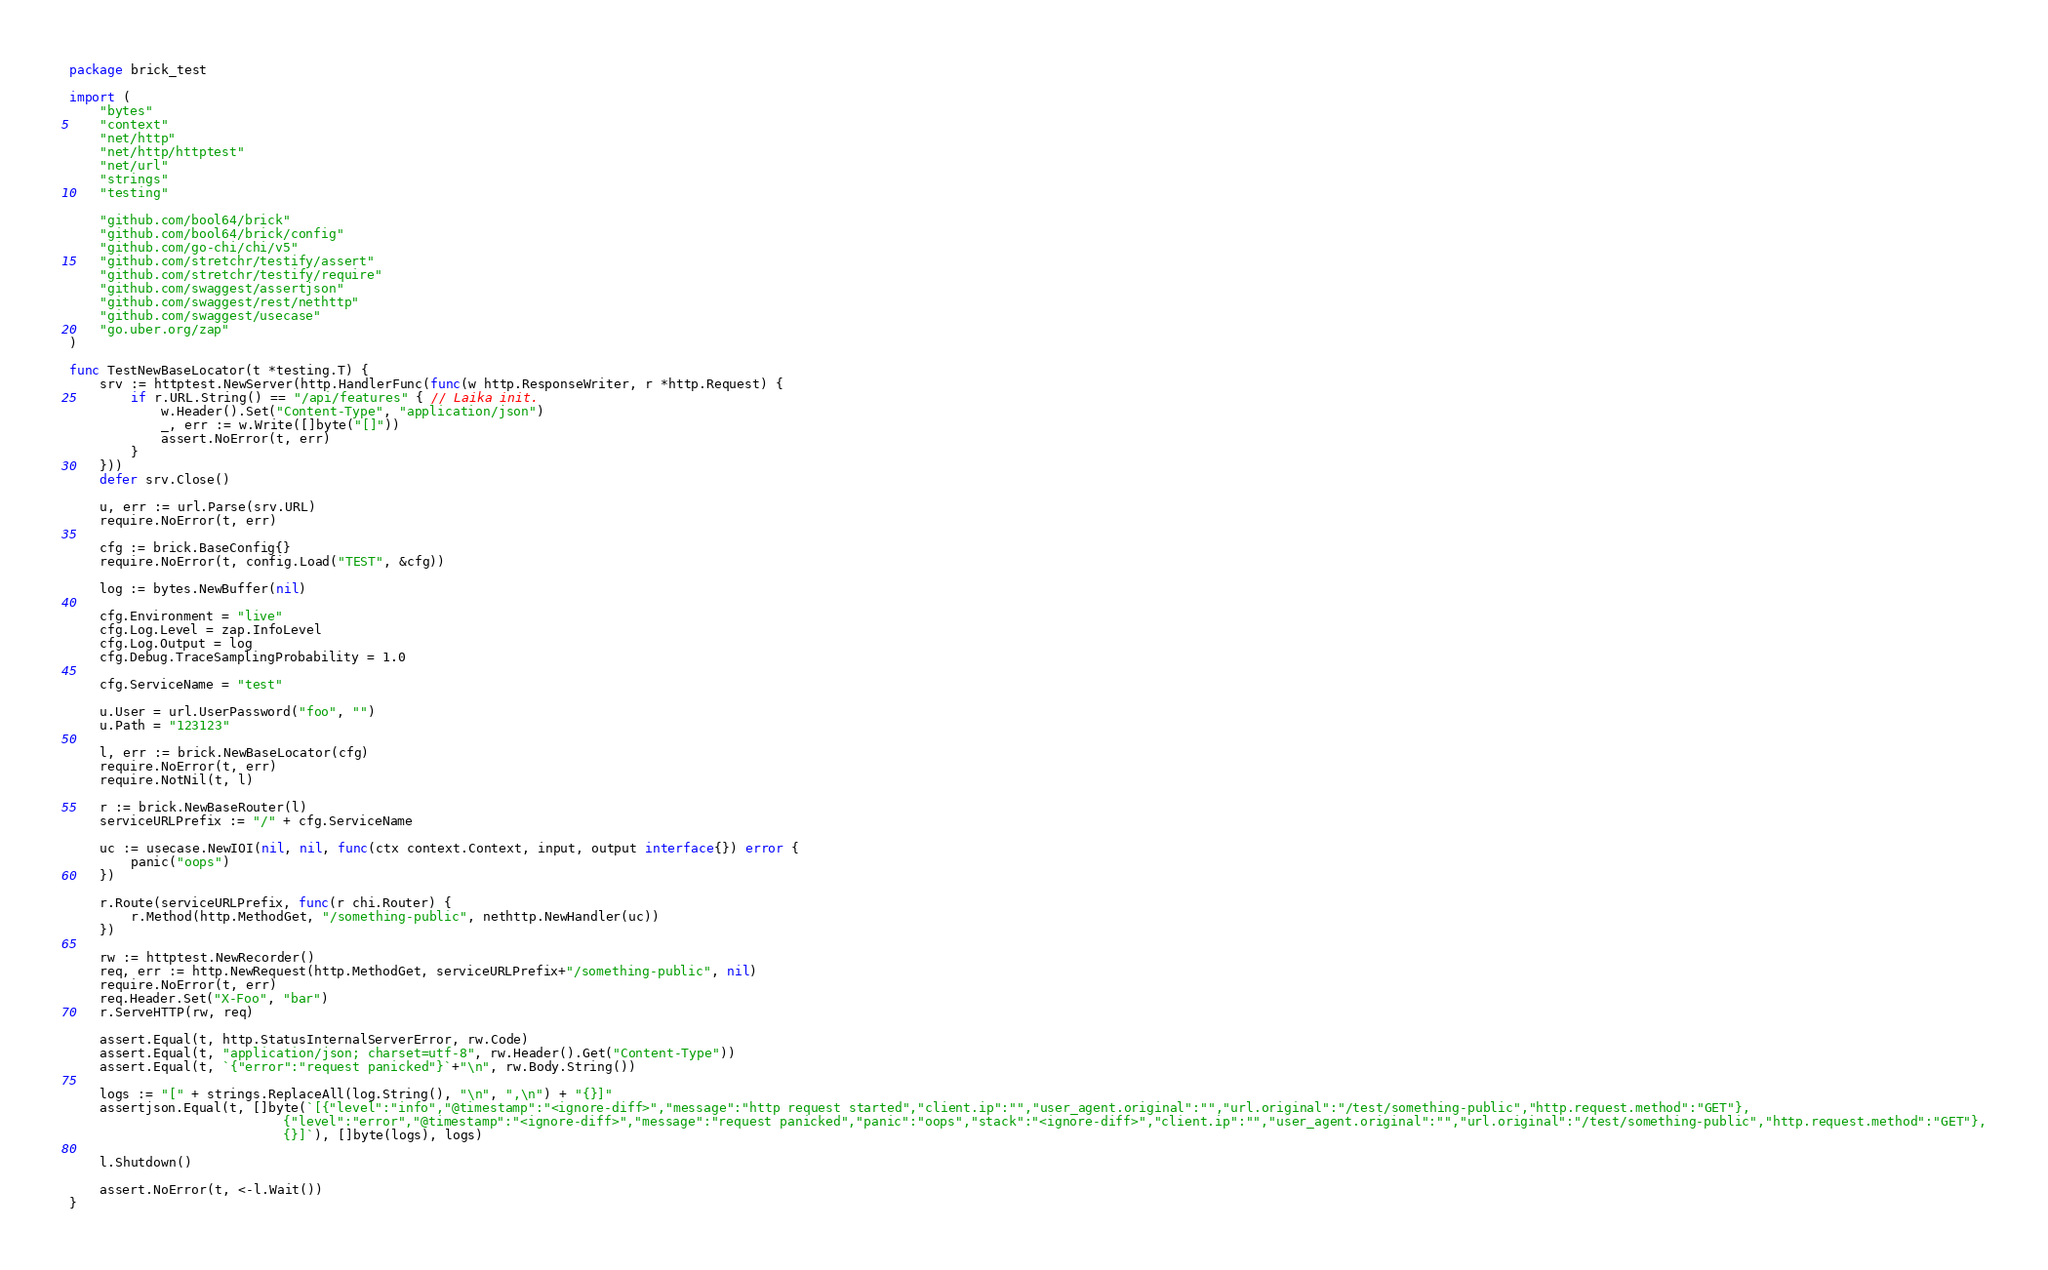Convert code to text. <code><loc_0><loc_0><loc_500><loc_500><_Go_>package brick_test

import (
	"bytes"
	"context"
	"net/http"
	"net/http/httptest"
	"net/url"
	"strings"
	"testing"

	"github.com/bool64/brick"
	"github.com/bool64/brick/config"
	"github.com/go-chi/chi/v5"
	"github.com/stretchr/testify/assert"
	"github.com/stretchr/testify/require"
	"github.com/swaggest/assertjson"
	"github.com/swaggest/rest/nethttp"
	"github.com/swaggest/usecase"
	"go.uber.org/zap"
)

func TestNewBaseLocator(t *testing.T) {
	srv := httptest.NewServer(http.HandlerFunc(func(w http.ResponseWriter, r *http.Request) {
		if r.URL.String() == "/api/features" { // Laika init.
			w.Header().Set("Content-Type", "application/json")
			_, err := w.Write([]byte("[]"))
			assert.NoError(t, err)
		}
	}))
	defer srv.Close()

	u, err := url.Parse(srv.URL)
	require.NoError(t, err)

	cfg := brick.BaseConfig{}
	require.NoError(t, config.Load("TEST", &cfg))

	log := bytes.NewBuffer(nil)

	cfg.Environment = "live"
	cfg.Log.Level = zap.InfoLevel
	cfg.Log.Output = log
	cfg.Debug.TraceSamplingProbability = 1.0

	cfg.ServiceName = "test"

	u.User = url.UserPassword("foo", "")
	u.Path = "123123"

	l, err := brick.NewBaseLocator(cfg)
	require.NoError(t, err)
	require.NotNil(t, l)

	r := brick.NewBaseRouter(l)
	serviceURLPrefix := "/" + cfg.ServiceName

	uc := usecase.NewIOI(nil, nil, func(ctx context.Context, input, output interface{}) error {
		panic("oops")
	})

	r.Route(serviceURLPrefix, func(r chi.Router) {
		r.Method(http.MethodGet, "/something-public", nethttp.NewHandler(uc))
	})

	rw := httptest.NewRecorder()
	req, err := http.NewRequest(http.MethodGet, serviceURLPrefix+"/something-public", nil)
	require.NoError(t, err)
	req.Header.Set("X-Foo", "bar")
	r.ServeHTTP(rw, req)

	assert.Equal(t, http.StatusInternalServerError, rw.Code)
	assert.Equal(t, "application/json; charset=utf-8", rw.Header().Get("Content-Type"))
	assert.Equal(t, `{"error":"request panicked"}`+"\n", rw.Body.String())

	logs := "[" + strings.ReplaceAll(log.String(), "\n", ",\n") + "{}]"
	assertjson.Equal(t, []byte(`[{"level":"info","@timestamp":"<ignore-diff>","message":"http request started","client.ip":"","user_agent.original":"","url.original":"/test/something-public","http.request.method":"GET"},
        	            	{"level":"error","@timestamp":"<ignore-diff>","message":"request panicked","panic":"oops","stack":"<ignore-diff>","client.ip":"","user_agent.original":"","url.original":"/test/something-public","http.request.method":"GET"},
        	            	{}]`), []byte(logs), logs)

	l.Shutdown()

	assert.NoError(t, <-l.Wait())
}
</code> 